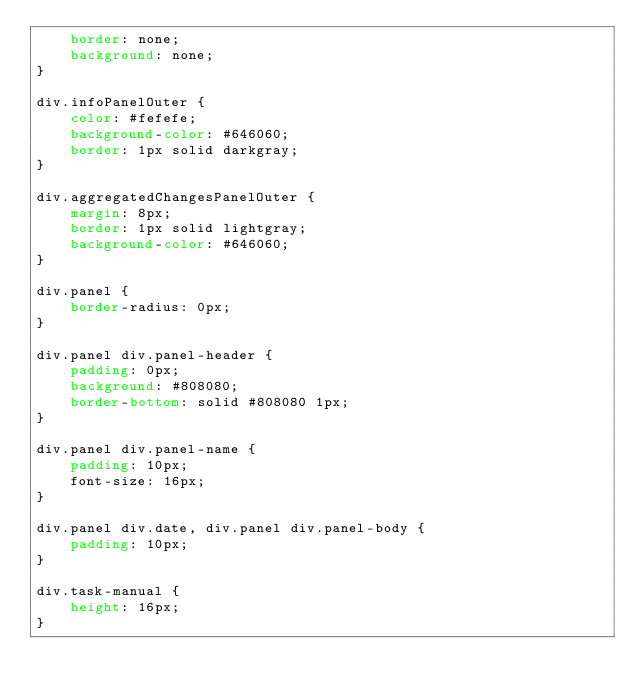Convert code to text. <code><loc_0><loc_0><loc_500><loc_500><_CSS_>    border: none;
    background: none;
}

div.infoPanelOuter {
    color: #fefefe;
    background-color: #646060;
    border: 1px solid darkgray;
}

div.aggregatedChangesPanelOuter {
    margin: 8px;
    border: 1px solid lightgray;
    background-color: #646060;
}

div.panel {
    border-radius: 0px;
}

div.panel div.panel-header {
    padding: 0px;
    background: #808080;
    border-bottom: solid #808080 1px;
}

div.panel div.panel-name {
    padding: 10px;
    font-size: 16px;
}

div.panel div.date, div.panel div.panel-body {
    padding: 10px;
}

div.task-manual {
    height: 16px;
}
</code> 